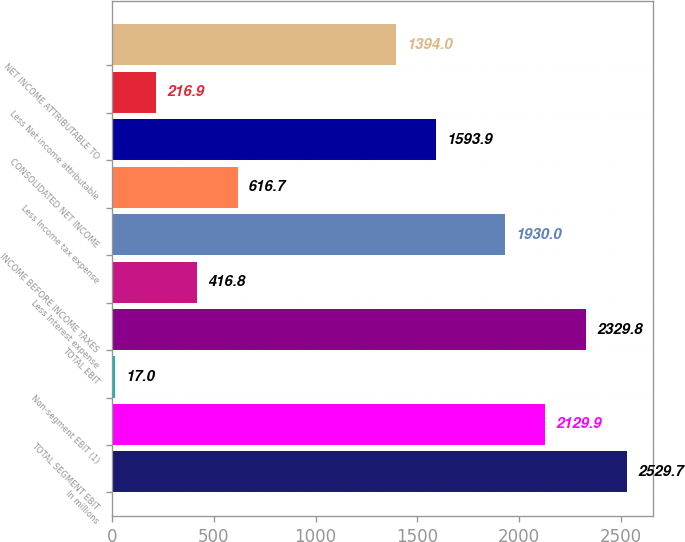Convert chart to OTSL. <chart><loc_0><loc_0><loc_500><loc_500><bar_chart><fcel>In millions<fcel>TOTAL SEGMENT EBIT<fcel>Non-segment EBIT (1)<fcel>TOTAL EBIT<fcel>Less Interest expense<fcel>INCOME BEFORE INCOME TAXES<fcel>Less Income tax expense<fcel>CONSOLIDATED NET INCOME<fcel>Less Net income attributable<fcel>NET INCOME ATTRIBUTABLE TO<nl><fcel>2529.7<fcel>2129.9<fcel>17<fcel>2329.8<fcel>416.8<fcel>1930<fcel>616.7<fcel>1593.9<fcel>216.9<fcel>1394<nl></chart> 